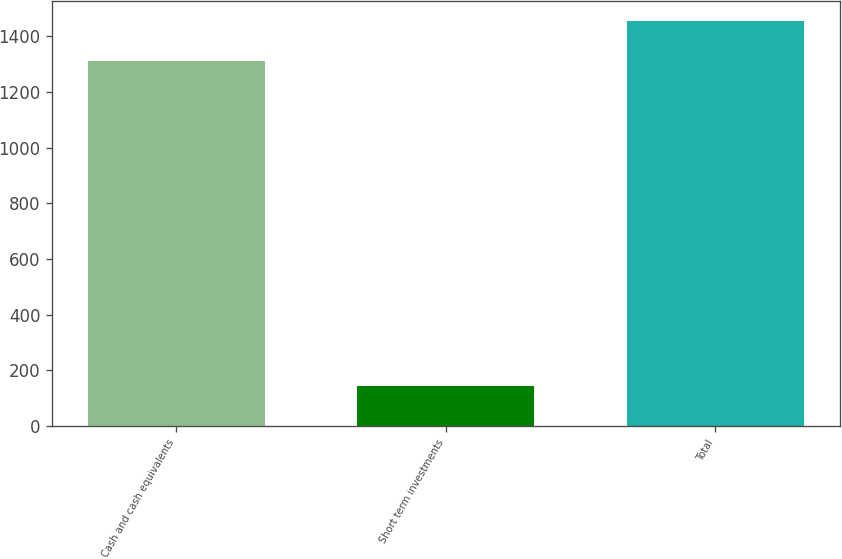Convert chart. <chart><loc_0><loc_0><loc_500><loc_500><bar_chart><fcel>Cash and cash equivalents<fcel>Short term investments<fcel>Total<nl><fcel>1311<fcel>144<fcel>1455<nl></chart> 